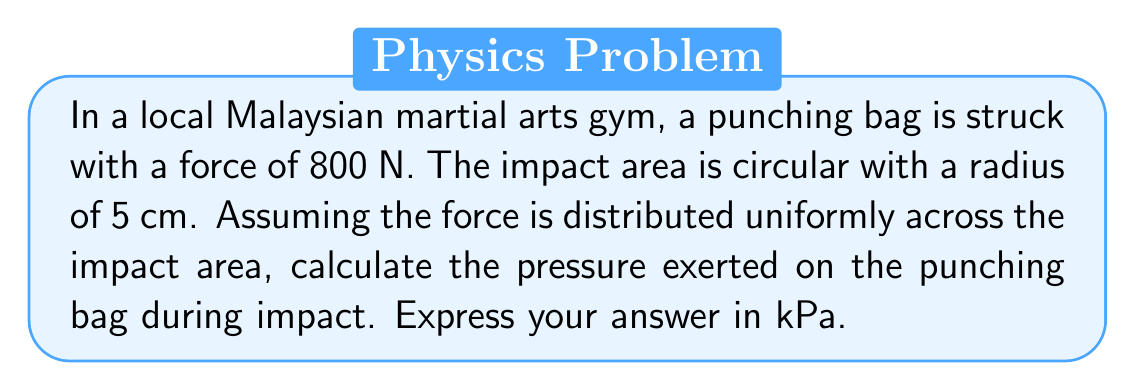Can you solve this math problem? To solve this problem, we'll follow these steps:

1. Identify the given information:
   - Force (F) = 800 N
   - Radius of impact area (r) = 5 cm = 0.05 m

2. Calculate the area of impact:
   The impact area is circular, so we use the formula for the area of a circle:
   $$A = \pi r^2$$
   $$A = \pi (0.05 \text{ m})^2 = 0.00785 \text{ m}^2$$

3. Calculate the pressure using the formula:
   $$P = \frac{F}{A}$$
   Where:
   P = Pressure
   F = Force
   A = Area

   Substituting the values:
   $$P = \frac{800 \text{ N}}{0.00785 \text{ m}^2} = 101,910.83 \text{ Pa}$$

4. Convert the result to kPa:
   $$101,910.83 \text{ Pa} \times \frac{1 \text{ kPa}}{1000 \text{ Pa}} = 101.91 \text{ kPa}$$

Therefore, the pressure exerted on the punching bag during impact is approximately 101.91 kPa.
Answer: 101.91 kPa 